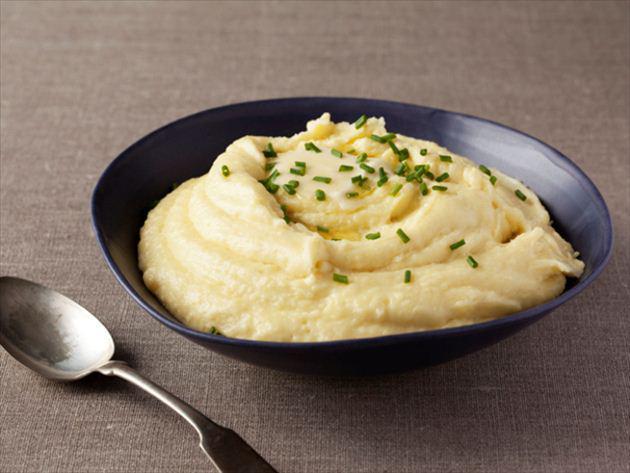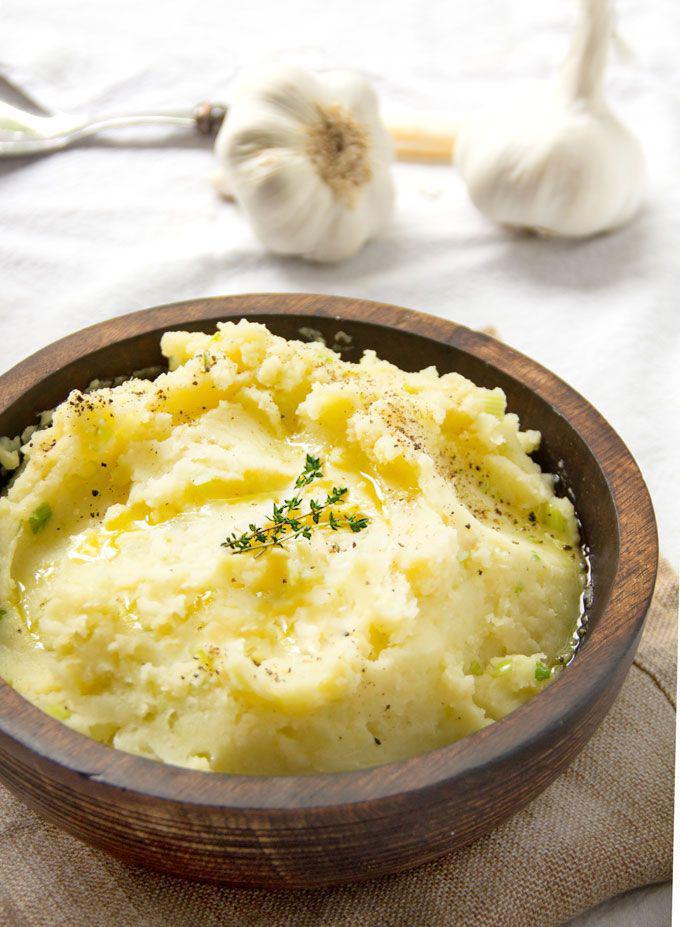The first image is the image on the left, the second image is the image on the right. Evaluate the accuracy of this statement regarding the images: "There is a silver spoon near the bowl of food in the image on the left.". Is it true? Answer yes or no. Yes. The first image is the image on the left, the second image is the image on the right. For the images displayed, is the sentence "Left image shows a silver spoon next to a bowl of mashed potatoes." factually correct? Answer yes or no. Yes. 